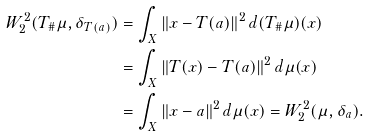<formula> <loc_0><loc_0><loc_500><loc_500>W _ { 2 } ^ { 2 } ( T _ { \# } \mu , \delta _ { T ( a ) } ) & = \int _ { X } \| x - T ( a ) \| ^ { 2 } \, d ( T _ { \# } \mu ) ( x ) \\ & = \int _ { X } \| T ( x ) - T ( a ) \| ^ { 2 } \, d \mu ( x ) \\ & = \int _ { X } \| x - a \| ^ { 2 } \, d \mu ( x ) = W _ { 2 } ^ { 2 } ( \mu , \delta _ { a } ) .</formula> 